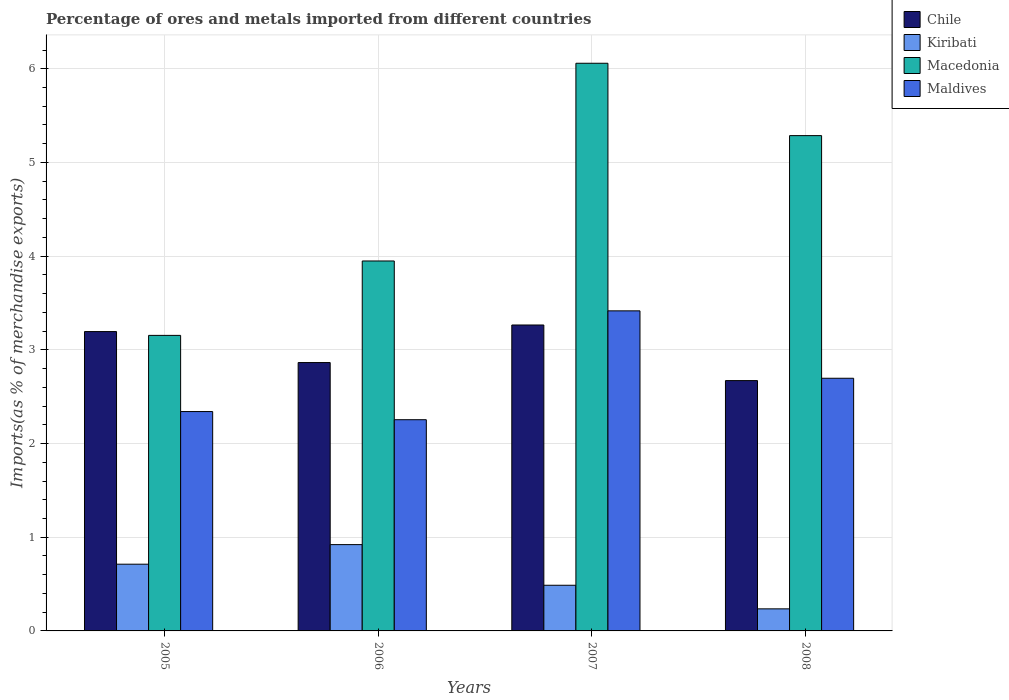How many different coloured bars are there?
Your answer should be compact. 4. How many groups of bars are there?
Give a very brief answer. 4. Are the number of bars per tick equal to the number of legend labels?
Offer a terse response. Yes. How many bars are there on the 3rd tick from the left?
Make the answer very short. 4. How many bars are there on the 3rd tick from the right?
Your answer should be very brief. 4. What is the label of the 1st group of bars from the left?
Your answer should be very brief. 2005. In how many cases, is the number of bars for a given year not equal to the number of legend labels?
Offer a very short reply. 0. What is the percentage of imports to different countries in Chile in 2008?
Provide a succinct answer. 2.67. Across all years, what is the maximum percentage of imports to different countries in Maldives?
Provide a short and direct response. 3.42. Across all years, what is the minimum percentage of imports to different countries in Macedonia?
Provide a succinct answer. 3.15. What is the total percentage of imports to different countries in Macedonia in the graph?
Offer a very short reply. 18.45. What is the difference between the percentage of imports to different countries in Maldives in 2006 and that in 2008?
Keep it short and to the point. -0.44. What is the difference between the percentage of imports to different countries in Kiribati in 2008 and the percentage of imports to different countries in Macedonia in 2005?
Your answer should be very brief. -2.92. What is the average percentage of imports to different countries in Macedonia per year?
Provide a short and direct response. 4.61. In the year 2005, what is the difference between the percentage of imports to different countries in Kiribati and percentage of imports to different countries in Macedonia?
Keep it short and to the point. -2.44. In how many years, is the percentage of imports to different countries in Chile greater than 3.4 %?
Your answer should be very brief. 0. What is the ratio of the percentage of imports to different countries in Chile in 2007 to that in 2008?
Make the answer very short. 1.22. Is the percentage of imports to different countries in Chile in 2005 less than that in 2008?
Give a very brief answer. No. What is the difference between the highest and the second highest percentage of imports to different countries in Chile?
Your answer should be very brief. 0.07. What is the difference between the highest and the lowest percentage of imports to different countries in Chile?
Make the answer very short. 0.59. In how many years, is the percentage of imports to different countries in Maldives greater than the average percentage of imports to different countries in Maldives taken over all years?
Offer a terse response. 2. What does the 1st bar from the left in 2008 represents?
Offer a terse response. Chile. What does the 4th bar from the right in 2008 represents?
Your answer should be very brief. Chile. What is the difference between two consecutive major ticks on the Y-axis?
Offer a terse response. 1. Does the graph contain any zero values?
Offer a terse response. No. How many legend labels are there?
Make the answer very short. 4. What is the title of the graph?
Your answer should be compact. Percentage of ores and metals imported from different countries. What is the label or title of the Y-axis?
Give a very brief answer. Imports(as % of merchandise exports). What is the Imports(as % of merchandise exports) in Chile in 2005?
Ensure brevity in your answer.  3.2. What is the Imports(as % of merchandise exports) of Kiribati in 2005?
Your answer should be compact. 0.71. What is the Imports(as % of merchandise exports) of Macedonia in 2005?
Ensure brevity in your answer.  3.15. What is the Imports(as % of merchandise exports) of Maldives in 2005?
Provide a short and direct response. 2.34. What is the Imports(as % of merchandise exports) in Chile in 2006?
Provide a short and direct response. 2.86. What is the Imports(as % of merchandise exports) in Kiribati in 2006?
Your answer should be very brief. 0.92. What is the Imports(as % of merchandise exports) of Macedonia in 2006?
Give a very brief answer. 3.95. What is the Imports(as % of merchandise exports) of Maldives in 2006?
Your answer should be very brief. 2.25. What is the Imports(as % of merchandise exports) in Chile in 2007?
Make the answer very short. 3.27. What is the Imports(as % of merchandise exports) in Kiribati in 2007?
Provide a short and direct response. 0.49. What is the Imports(as % of merchandise exports) of Macedonia in 2007?
Your response must be concise. 6.06. What is the Imports(as % of merchandise exports) of Maldives in 2007?
Offer a terse response. 3.42. What is the Imports(as % of merchandise exports) in Chile in 2008?
Your answer should be compact. 2.67. What is the Imports(as % of merchandise exports) in Kiribati in 2008?
Provide a short and direct response. 0.24. What is the Imports(as % of merchandise exports) of Macedonia in 2008?
Keep it short and to the point. 5.29. What is the Imports(as % of merchandise exports) in Maldives in 2008?
Offer a terse response. 2.7. Across all years, what is the maximum Imports(as % of merchandise exports) in Chile?
Your answer should be compact. 3.27. Across all years, what is the maximum Imports(as % of merchandise exports) of Kiribati?
Make the answer very short. 0.92. Across all years, what is the maximum Imports(as % of merchandise exports) in Macedonia?
Give a very brief answer. 6.06. Across all years, what is the maximum Imports(as % of merchandise exports) of Maldives?
Your response must be concise. 3.42. Across all years, what is the minimum Imports(as % of merchandise exports) in Chile?
Give a very brief answer. 2.67. Across all years, what is the minimum Imports(as % of merchandise exports) of Kiribati?
Your answer should be compact. 0.24. Across all years, what is the minimum Imports(as % of merchandise exports) of Macedonia?
Provide a short and direct response. 3.15. Across all years, what is the minimum Imports(as % of merchandise exports) of Maldives?
Provide a short and direct response. 2.25. What is the total Imports(as % of merchandise exports) of Chile in the graph?
Your response must be concise. 12. What is the total Imports(as % of merchandise exports) of Kiribati in the graph?
Offer a terse response. 2.36. What is the total Imports(as % of merchandise exports) in Macedonia in the graph?
Give a very brief answer. 18.45. What is the total Imports(as % of merchandise exports) in Maldives in the graph?
Offer a terse response. 10.71. What is the difference between the Imports(as % of merchandise exports) of Chile in 2005 and that in 2006?
Your answer should be very brief. 0.33. What is the difference between the Imports(as % of merchandise exports) in Kiribati in 2005 and that in 2006?
Provide a succinct answer. -0.21. What is the difference between the Imports(as % of merchandise exports) of Macedonia in 2005 and that in 2006?
Offer a terse response. -0.79. What is the difference between the Imports(as % of merchandise exports) of Maldives in 2005 and that in 2006?
Ensure brevity in your answer.  0.09. What is the difference between the Imports(as % of merchandise exports) of Chile in 2005 and that in 2007?
Offer a very short reply. -0.07. What is the difference between the Imports(as % of merchandise exports) of Kiribati in 2005 and that in 2007?
Your response must be concise. 0.22. What is the difference between the Imports(as % of merchandise exports) in Macedonia in 2005 and that in 2007?
Offer a very short reply. -2.9. What is the difference between the Imports(as % of merchandise exports) of Maldives in 2005 and that in 2007?
Your response must be concise. -1.07. What is the difference between the Imports(as % of merchandise exports) of Chile in 2005 and that in 2008?
Your answer should be very brief. 0.52. What is the difference between the Imports(as % of merchandise exports) of Kiribati in 2005 and that in 2008?
Keep it short and to the point. 0.48. What is the difference between the Imports(as % of merchandise exports) of Macedonia in 2005 and that in 2008?
Give a very brief answer. -2.13. What is the difference between the Imports(as % of merchandise exports) of Maldives in 2005 and that in 2008?
Your answer should be compact. -0.36. What is the difference between the Imports(as % of merchandise exports) of Chile in 2006 and that in 2007?
Make the answer very short. -0.4. What is the difference between the Imports(as % of merchandise exports) of Kiribati in 2006 and that in 2007?
Offer a terse response. 0.43. What is the difference between the Imports(as % of merchandise exports) in Macedonia in 2006 and that in 2007?
Your response must be concise. -2.11. What is the difference between the Imports(as % of merchandise exports) of Maldives in 2006 and that in 2007?
Keep it short and to the point. -1.16. What is the difference between the Imports(as % of merchandise exports) of Chile in 2006 and that in 2008?
Your answer should be very brief. 0.19. What is the difference between the Imports(as % of merchandise exports) in Kiribati in 2006 and that in 2008?
Give a very brief answer. 0.69. What is the difference between the Imports(as % of merchandise exports) in Macedonia in 2006 and that in 2008?
Make the answer very short. -1.34. What is the difference between the Imports(as % of merchandise exports) of Maldives in 2006 and that in 2008?
Keep it short and to the point. -0.44. What is the difference between the Imports(as % of merchandise exports) in Chile in 2007 and that in 2008?
Your answer should be compact. 0.59. What is the difference between the Imports(as % of merchandise exports) in Kiribati in 2007 and that in 2008?
Your answer should be very brief. 0.25. What is the difference between the Imports(as % of merchandise exports) of Macedonia in 2007 and that in 2008?
Your answer should be very brief. 0.77. What is the difference between the Imports(as % of merchandise exports) of Maldives in 2007 and that in 2008?
Your response must be concise. 0.72. What is the difference between the Imports(as % of merchandise exports) in Chile in 2005 and the Imports(as % of merchandise exports) in Kiribati in 2006?
Make the answer very short. 2.27. What is the difference between the Imports(as % of merchandise exports) of Chile in 2005 and the Imports(as % of merchandise exports) of Macedonia in 2006?
Give a very brief answer. -0.75. What is the difference between the Imports(as % of merchandise exports) of Chile in 2005 and the Imports(as % of merchandise exports) of Maldives in 2006?
Your answer should be compact. 0.94. What is the difference between the Imports(as % of merchandise exports) in Kiribati in 2005 and the Imports(as % of merchandise exports) in Macedonia in 2006?
Make the answer very short. -3.24. What is the difference between the Imports(as % of merchandise exports) of Kiribati in 2005 and the Imports(as % of merchandise exports) of Maldives in 2006?
Your answer should be very brief. -1.54. What is the difference between the Imports(as % of merchandise exports) in Macedonia in 2005 and the Imports(as % of merchandise exports) in Maldives in 2006?
Your answer should be very brief. 0.9. What is the difference between the Imports(as % of merchandise exports) of Chile in 2005 and the Imports(as % of merchandise exports) of Kiribati in 2007?
Provide a short and direct response. 2.71. What is the difference between the Imports(as % of merchandise exports) in Chile in 2005 and the Imports(as % of merchandise exports) in Macedonia in 2007?
Offer a terse response. -2.86. What is the difference between the Imports(as % of merchandise exports) of Chile in 2005 and the Imports(as % of merchandise exports) of Maldives in 2007?
Ensure brevity in your answer.  -0.22. What is the difference between the Imports(as % of merchandise exports) of Kiribati in 2005 and the Imports(as % of merchandise exports) of Macedonia in 2007?
Your response must be concise. -5.35. What is the difference between the Imports(as % of merchandise exports) in Kiribati in 2005 and the Imports(as % of merchandise exports) in Maldives in 2007?
Provide a short and direct response. -2.7. What is the difference between the Imports(as % of merchandise exports) of Macedonia in 2005 and the Imports(as % of merchandise exports) of Maldives in 2007?
Ensure brevity in your answer.  -0.26. What is the difference between the Imports(as % of merchandise exports) of Chile in 2005 and the Imports(as % of merchandise exports) of Kiribati in 2008?
Make the answer very short. 2.96. What is the difference between the Imports(as % of merchandise exports) of Chile in 2005 and the Imports(as % of merchandise exports) of Macedonia in 2008?
Your answer should be very brief. -2.09. What is the difference between the Imports(as % of merchandise exports) in Chile in 2005 and the Imports(as % of merchandise exports) in Maldives in 2008?
Your response must be concise. 0.5. What is the difference between the Imports(as % of merchandise exports) in Kiribati in 2005 and the Imports(as % of merchandise exports) in Macedonia in 2008?
Ensure brevity in your answer.  -4.57. What is the difference between the Imports(as % of merchandise exports) in Kiribati in 2005 and the Imports(as % of merchandise exports) in Maldives in 2008?
Your response must be concise. -1.98. What is the difference between the Imports(as % of merchandise exports) of Macedonia in 2005 and the Imports(as % of merchandise exports) of Maldives in 2008?
Ensure brevity in your answer.  0.46. What is the difference between the Imports(as % of merchandise exports) in Chile in 2006 and the Imports(as % of merchandise exports) in Kiribati in 2007?
Make the answer very short. 2.38. What is the difference between the Imports(as % of merchandise exports) of Chile in 2006 and the Imports(as % of merchandise exports) of Macedonia in 2007?
Offer a very short reply. -3.19. What is the difference between the Imports(as % of merchandise exports) of Chile in 2006 and the Imports(as % of merchandise exports) of Maldives in 2007?
Give a very brief answer. -0.55. What is the difference between the Imports(as % of merchandise exports) of Kiribati in 2006 and the Imports(as % of merchandise exports) of Macedonia in 2007?
Your answer should be very brief. -5.14. What is the difference between the Imports(as % of merchandise exports) of Kiribati in 2006 and the Imports(as % of merchandise exports) of Maldives in 2007?
Offer a very short reply. -2.5. What is the difference between the Imports(as % of merchandise exports) in Macedonia in 2006 and the Imports(as % of merchandise exports) in Maldives in 2007?
Provide a short and direct response. 0.53. What is the difference between the Imports(as % of merchandise exports) in Chile in 2006 and the Imports(as % of merchandise exports) in Kiribati in 2008?
Your answer should be compact. 2.63. What is the difference between the Imports(as % of merchandise exports) in Chile in 2006 and the Imports(as % of merchandise exports) in Macedonia in 2008?
Offer a very short reply. -2.42. What is the difference between the Imports(as % of merchandise exports) of Chile in 2006 and the Imports(as % of merchandise exports) of Maldives in 2008?
Make the answer very short. 0.17. What is the difference between the Imports(as % of merchandise exports) of Kiribati in 2006 and the Imports(as % of merchandise exports) of Macedonia in 2008?
Give a very brief answer. -4.37. What is the difference between the Imports(as % of merchandise exports) of Kiribati in 2006 and the Imports(as % of merchandise exports) of Maldives in 2008?
Make the answer very short. -1.78. What is the difference between the Imports(as % of merchandise exports) in Macedonia in 2006 and the Imports(as % of merchandise exports) in Maldives in 2008?
Offer a very short reply. 1.25. What is the difference between the Imports(as % of merchandise exports) of Chile in 2007 and the Imports(as % of merchandise exports) of Kiribati in 2008?
Offer a very short reply. 3.03. What is the difference between the Imports(as % of merchandise exports) in Chile in 2007 and the Imports(as % of merchandise exports) in Macedonia in 2008?
Offer a very short reply. -2.02. What is the difference between the Imports(as % of merchandise exports) in Chile in 2007 and the Imports(as % of merchandise exports) in Maldives in 2008?
Provide a succinct answer. 0.57. What is the difference between the Imports(as % of merchandise exports) in Kiribati in 2007 and the Imports(as % of merchandise exports) in Macedonia in 2008?
Provide a succinct answer. -4.8. What is the difference between the Imports(as % of merchandise exports) in Kiribati in 2007 and the Imports(as % of merchandise exports) in Maldives in 2008?
Offer a terse response. -2.21. What is the difference between the Imports(as % of merchandise exports) in Macedonia in 2007 and the Imports(as % of merchandise exports) in Maldives in 2008?
Offer a very short reply. 3.36. What is the average Imports(as % of merchandise exports) of Chile per year?
Provide a succinct answer. 3. What is the average Imports(as % of merchandise exports) of Kiribati per year?
Give a very brief answer. 0.59. What is the average Imports(as % of merchandise exports) of Macedonia per year?
Make the answer very short. 4.61. What is the average Imports(as % of merchandise exports) in Maldives per year?
Offer a very short reply. 2.68. In the year 2005, what is the difference between the Imports(as % of merchandise exports) in Chile and Imports(as % of merchandise exports) in Kiribati?
Offer a very short reply. 2.48. In the year 2005, what is the difference between the Imports(as % of merchandise exports) of Chile and Imports(as % of merchandise exports) of Macedonia?
Give a very brief answer. 0.04. In the year 2005, what is the difference between the Imports(as % of merchandise exports) in Chile and Imports(as % of merchandise exports) in Maldives?
Offer a terse response. 0.85. In the year 2005, what is the difference between the Imports(as % of merchandise exports) of Kiribati and Imports(as % of merchandise exports) of Macedonia?
Your answer should be compact. -2.44. In the year 2005, what is the difference between the Imports(as % of merchandise exports) of Kiribati and Imports(as % of merchandise exports) of Maldives?
Make the answer very short. -1.63. In the year 2005, what is the difference between the Imports(as % of merchandise exports) of Macedonia and Imports(as % of merchandise exports) of Maldives?
Your answer should be compact. 0.81. In the year 2006, what is the difference between the Imports(as % of merchandise exports) in Chile and Imports(as % of merchandise exports) in Kiribati?
Make the answer very short. 1.94. In the year 2006, what is the difference between the Imports(as % of merchandise exports) in Chile and Imports(as % of merchandise exports) in Macedonia?
Your answer should be very brief. -1.08. In the year 2006, what is the difference between the Imports(as % of merchandise exports) in Chile and Imports(as % of merchandise exports) in Maldives?
Offer a terse response. 0.61. In the year 2006, what is the difference between the Imports(as % of merchandise exports) of Kiribati and Imports(as % of merchandise exports) of Macedonia?
Provide a short and direct response. -3.03. In the year 2006, what is the difference between the Imports(as % of merchandise exports) in Kiribati and Imports(as % of merchandise exports) in Maldives?
Ensure brevity in your answer.  -1.33. In the year 2006, what is the difference between the Imports(as % of merchandise exports) in Macedonia and Imports(as % of merchandise exports) in Maldives?
Provide a succinct answer. 1.69. In the year 2007, what is the difference between the Imports(as % of merchandise exports) in Chile and Imports(as % of merchandise exports) in Kiribati?
Keep it short and to the point. 2.78. In the year 2007, what is the difference between the Imports(as % of merchandise exports) in Chile and Imports(as % of merchandise exports) in Macedonia?
Offer a terse response. -2.79. In the year 2007, what is the difference between the Imports(as % of merchandise exports) of Chile and Imports(as % of merchandise exports) of Maldives?
Offer a very short reply. -0.15. In the year 2007, what is the difference between the Imports(as % of merchandise exports) of Kiribati and Imports(as % of merchandise exports) of Macedonia?
Your answer should be compact. -5.57. In the year 2007, what is the difference between the Imports(as % of merchandise exports) of Kiribati and Imports(as % of merchandise exports) of Maldives?
Make the answer very short. -2.93. In the year 2007, what is the difference between the Imports(as % of merchandise exports) in Macedonia and Imports(as % of merchandise exports) in Maldives?
Provide a short and direct response. 2.64. In the year 2008, what is the difference between the Imports(as % of merchandise exports) of Chile and Imports(as % of merchandise exports) of Kiribati?
Your answer should be compact. 2.44. In the year 2008, what is the difference between the Imports(as % of merchandise exports) in Chile and Imports(as % of merchandise exports) in Macedonia?
Your answer should be compact. -2.61. In the year 2008, what is the difference between the Imports(as % of merchandise exports) of Chile and Imports(as % of merchandise exports) of Maldives?
Make the answer very short. -0.02. In the year 2008, what is the difference between the Imports(as % of merchandise exports) in Kiribati and Imports(as % of merchandise exports) in Macedonia?
Ensure brevity in your answer.  -5.05. In the year 2008, what is the difference between the Imports(as % of merchandise exports) of Kiribati and Imports(as % of merchandise exports) of Maldives?
Your answer should be compact. -2.46. In the year 2008, what is the difference between the Imports(as % of merchandise exports) in Macedonia and Imports(as % of merchandise exports) in Maldives?
Keep it short and to the point. 2.59. What is the ratio of the Imports(as % of merchandise exports) in Chile in 2005 to that in 2006?
Your answer should be compact. 1.12. What is the ratio of the Imports(as % of merchandise exports) of Kiribati in 2005 to that in 2006?
Give a very brief answer. 0.77. What is the ratio of the Imports(as % of merchandise exports) of Macedonia in 2005 to that in 2006?
Provide a short and direct response. 0.8. What is the ratio of the Imports(as % of merchandise exports) in Maldives in 2005 to that in 2006?
Provide a short and direct response. 1.04. What is the ratio of the Imports(as % of merchandise exports) of Chile in 2005 to that in 2007?
Keep it short and to the point. 0.98. What is the ratio of the Imports(as % of merchandise exports) in Kiribati in 2005 to that in 2007?
Your response must be concise. 1.46. What is the ratio of the Imports(as % of merchandise exports) in Macedonia in 2005 to that in 2007?
Your response must be concise. 0.52. What is the ratio of the Imports(as % of merchandise exports) in Maldives in 2005 to that in 2007?
Ensure brevity in your answer.  0.69. What is the ratio of the Imports(as % of merchandise exports) of Chile in 2005 to that in 2008?
Your answer should be very brief. 1.2. What is the ratio of the Imports(as % of merchandise exports) of Kiribati in 2005 to that in 2008?
Your response must be concise. 3.02. What is the ratio of the Imports(as % of merchandise exports) in Macedonia in 2005 to that in 2008?
Make the answer very short. 0.6. What is the ratio of the Imports(as % of merchandise exports) of Maldives in 2005 to that in 2008?
Keep it short and to the point. 0.87. What is the ratio of the Imports(as % of merchandise exports) of Chile in 2006 to that in 2007?
Ensure brevity in your answer.  0.88. What is the ratio of the Imports(as % of merchandise exports) of Kiribati in 2006 to that in 2007?
Offer a terse response. 1.89. What is the ratio of the Imports(as % of merchandise exports) of Macedonia in 2006 to that in 2007?
Your response must be concise. 0.65. What is the ratio of the Imports(as % of merchandise exports) in Maldives in 2006 to that in 2007?
Make the answer very short. 0.66. What is the ratio of the Imports(as % of merchandise exports) of Chile in 2006 to that in 2008?
Your answer should be very brief. 1.07. What is the ratio of the Imports(as % of merchandise exports) of Kiribati in 2006 to that in 2008?
Keep it short and to the point. 3.91. What is the ratio of the Imports(as % of merchandise exports) of Macedonia in 2006 to that in 2008?
Make the answer very short. 0.75. What is the ratio of the Imports(as % of merchandise exports) of Maldives in 2006 to that in 2008?
Your answer should be compact. 0.84. What is the ratio of the Imports(as % of merchandise exports) in Chile in 2007 to that in 2008?
Give a very brief answer. 1.22. What is the ratio of the Imports(as % of merchandise exports) in Kiribati in 2007 to that in 2008?
Provide a short and direct response. 2.07. What is the ratio of the Imports(as % of merchandise exports) of Macedonia in 2007 to that in 2008?
Offer a very short reply. 1.15. What is the ratio of the Imports(as % of merchandise exports) of Maldives in 2007 to that in 2008?
Ensure brevity in your answer.  1.27. What is the difference between the highest and the second highest Imports(as % of merchandise exports) in Chile?
Provide a succinct answer. 0.07. What is the difference between the highest and the second highest Imports(as % of merchandise exports) of Kiribati?
Offer a very short reply. 0.21. What is the difference between the highest and the second highest Imports(as % of merchandise exports) of Macedonia?
Provide a short and direct response. 0.77. What is the difference between the highest and the second highest Imports(as % of merchandise exports) of Maldives?
Keep it short and to the point. 0.72. What is the difference between the highest and the lowest Imports(as % of merchandise exports) in Chile?
Give a very brief answer. 0.59. What is the difference between the highest and the lowest Imports(as % of merchandise exports) in Kiribati?
Offer a very short reply. 0.69. What is the difference between the highest and the lowest Imports(as % of merchandise exports) in Macedonia?
Your answer should be compact. 2.9. What is the difference between the highest and the lowest Imports(as % of merchandise exports) in Maldives?
Provide a short and direct response. 1.16. 